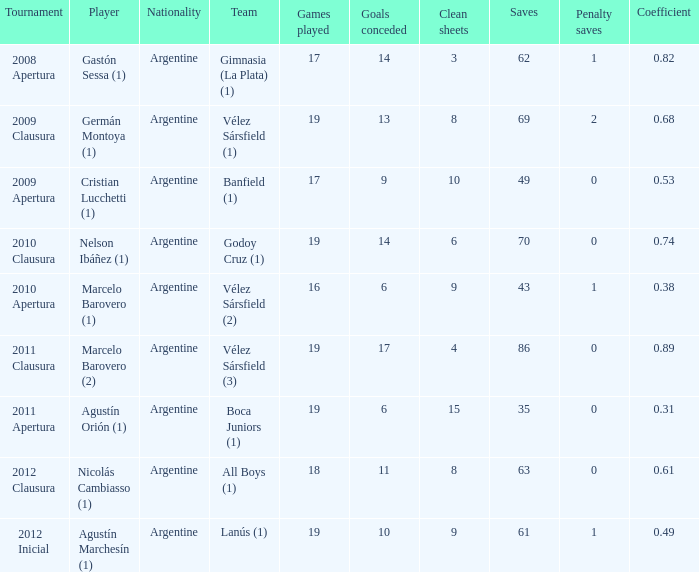 the 2010 clausura tournament? 0.74. 